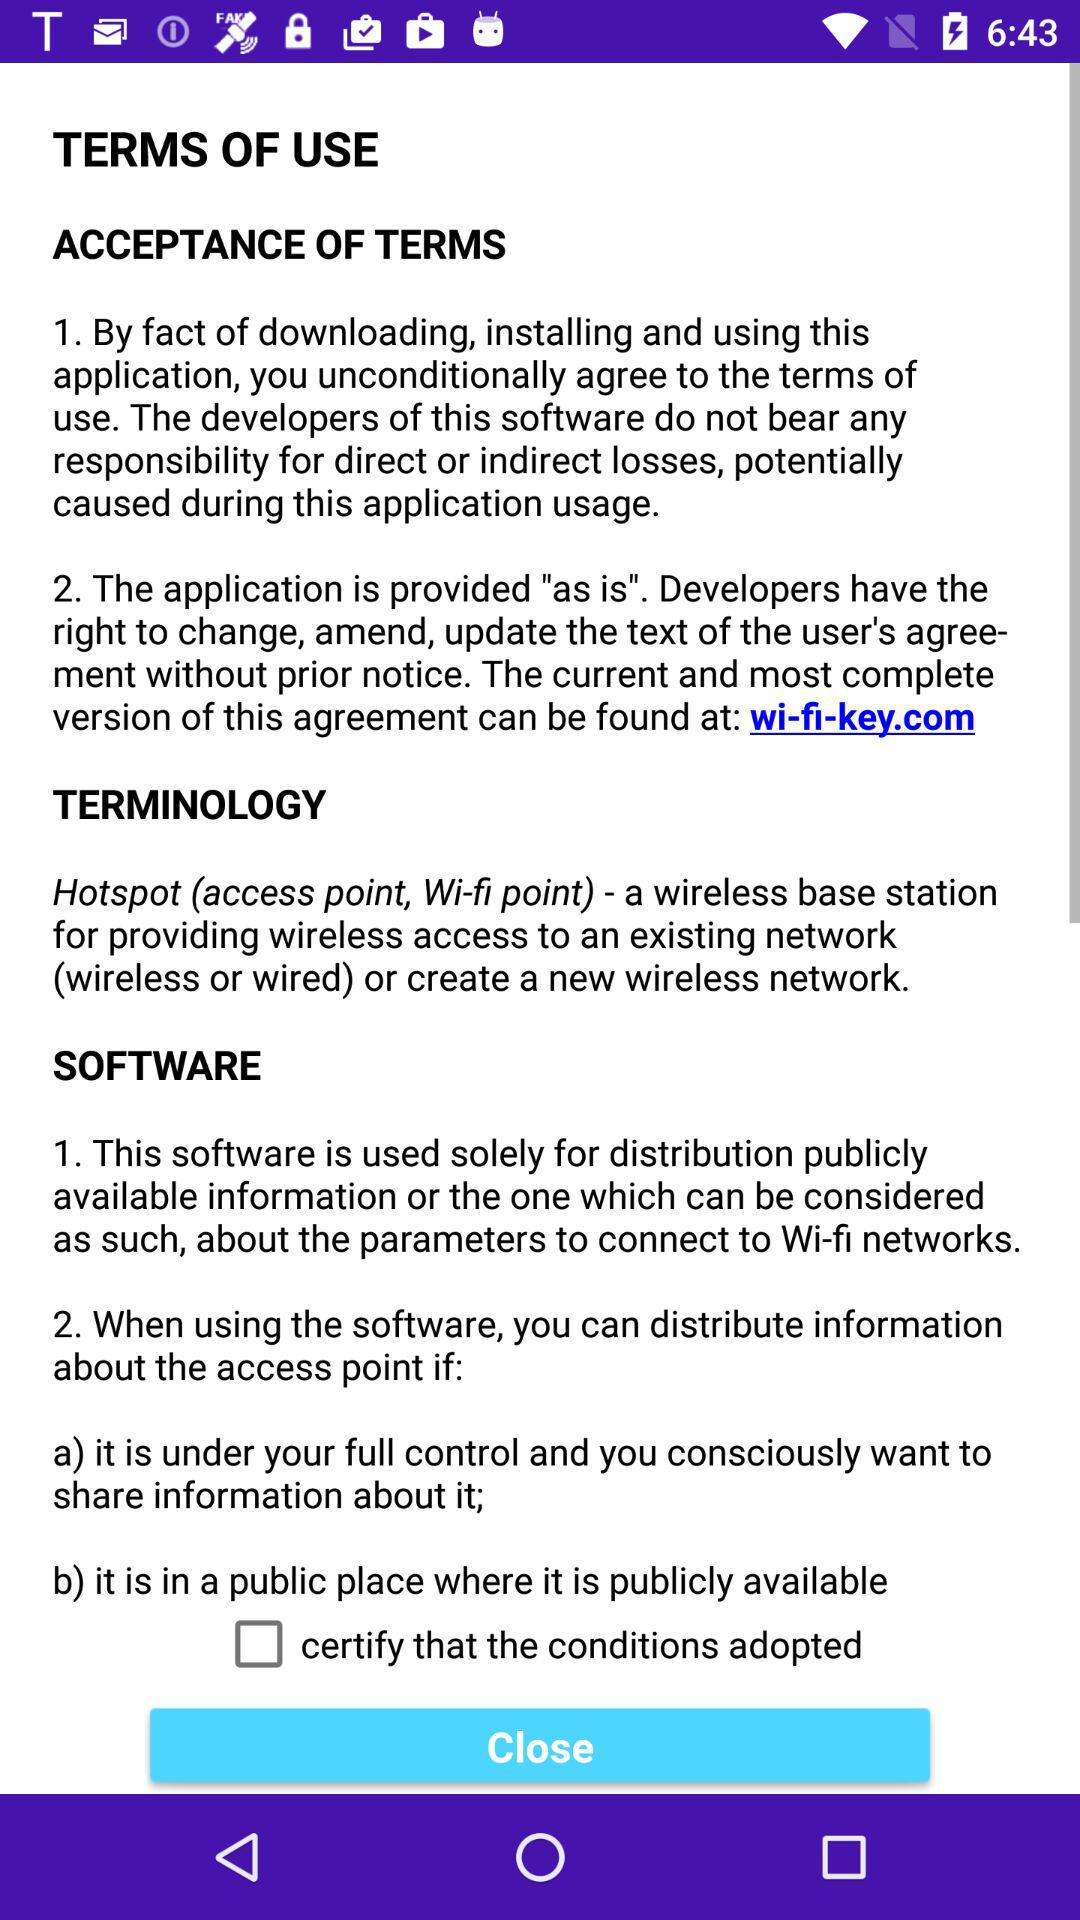What is the status of "certify that the conditions adopted"? The status is "off". 